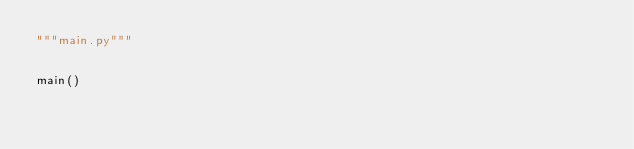<code> <loc_0><loc_0><loc_500><loc_500><_Python_>"""main.py"""


main()
</code> 